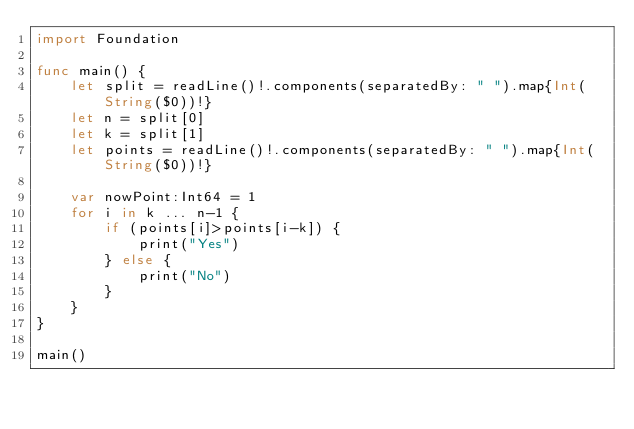<code> <loc_0><loc_0><loc_500><loc_500><_Swift_>import Foundation

func main() {
    let split = readLine()!.components(separatedBy: " ").map{Int(String($0))!}
    let n = split[0]
    let k = split[1]
    let points = readLine()!.components(separatedBy: " ").map{Int(String($0))!}

    var nowPoint:Int64 = 1
    for i in k ... n-1 {
        if (points[i]>points[i-k]) {
            print("Yes") 
        } else {
            print("No")
        }
    }
}

main()</code> 